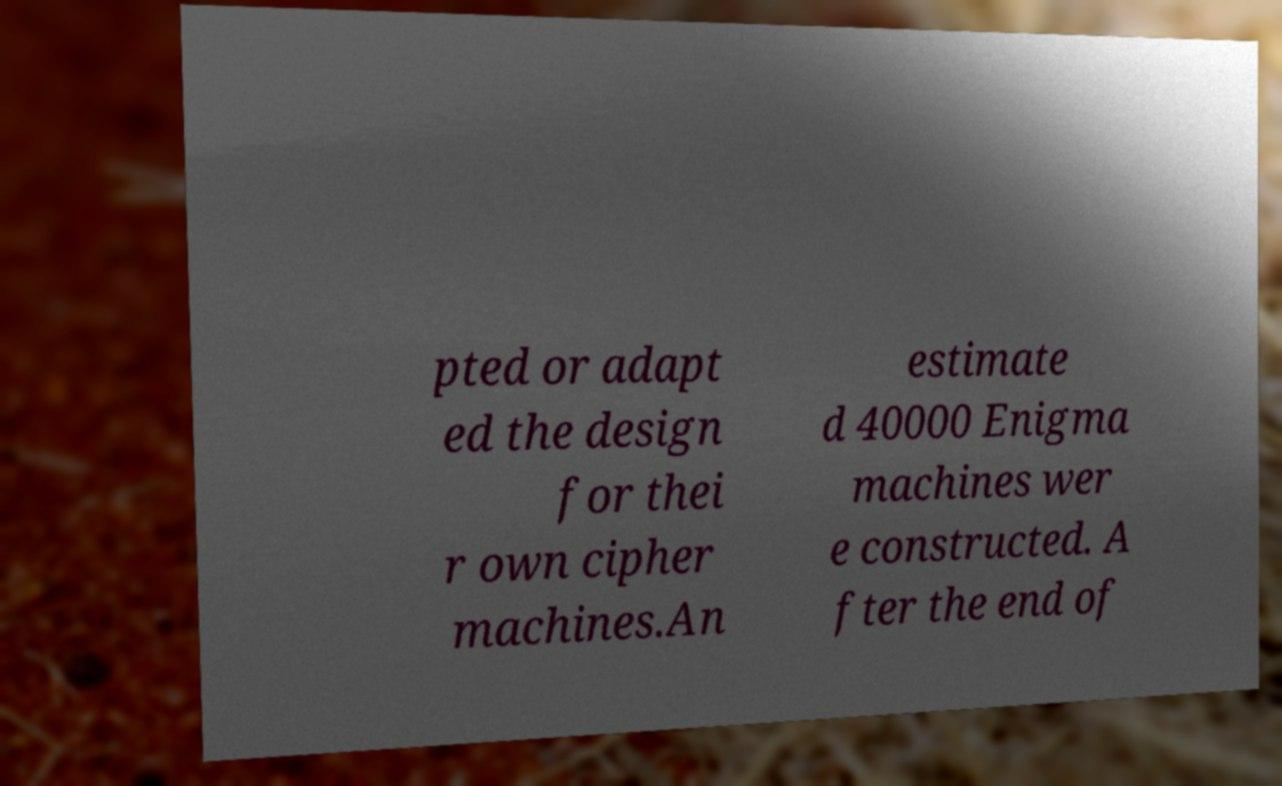Please identify and transcribe the text found in this image. pted or adapt ed the design for thei r own cipher machines.An estimate d 40000 Enigma machines wer e constructed. A fter the end of 